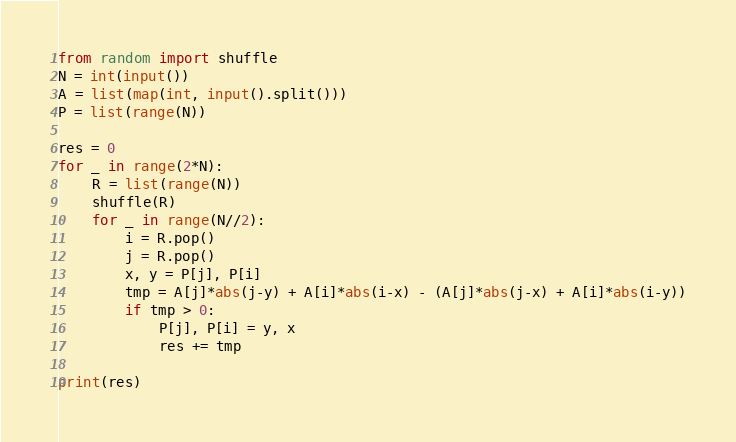<code> <loc_0><loc_0><loc_500><loc_500><_Python_>from random import shuffle
N = int(input())
A = list(map(int, input().split()))
P = list(range(N))

res = 0
for _ in range(2*N):
    R = list(range(N))
    shuffle(R)
    for _ in range(N//2):
        i = R.pop()
        j = R.pop()
        x, y = P[j], P[i]
        tmp = A[j]*abs(j-y) + A[i]*abs(i-x) - (A[j]*abs(j-x) + A[i]*abs(i-y))
        if tmp > 0:
            P[j], P[i] = y, x
            res += tmp

print(res)


</code> 